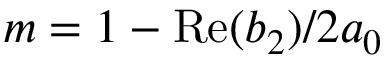<formula> <loc_0><loc_0><loc_500><loc_500>m = 1 - R e ( b _ { 2 } ) / 2 a _ { 0 }</formula> 